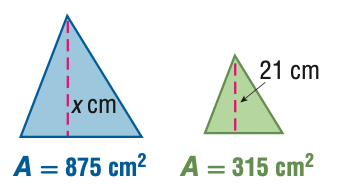Question: For the pair of similar figures, use the given areas to find x.
Choices:
A. 7.6
B. 12.6
C. 35
D. 58.3
Answer with the letter. Answer: C Question: For the pair of similar figures, use the given areas to find the scale factor from the blue to the green figure.
Choices:
A. \frac { 9 } { 25 }
B. \frac { 3 } { 5 }
C. \frac { 5 } { 3 }
D. \frac { 25 } { 9 }
Answer with the letter. Answer: C 